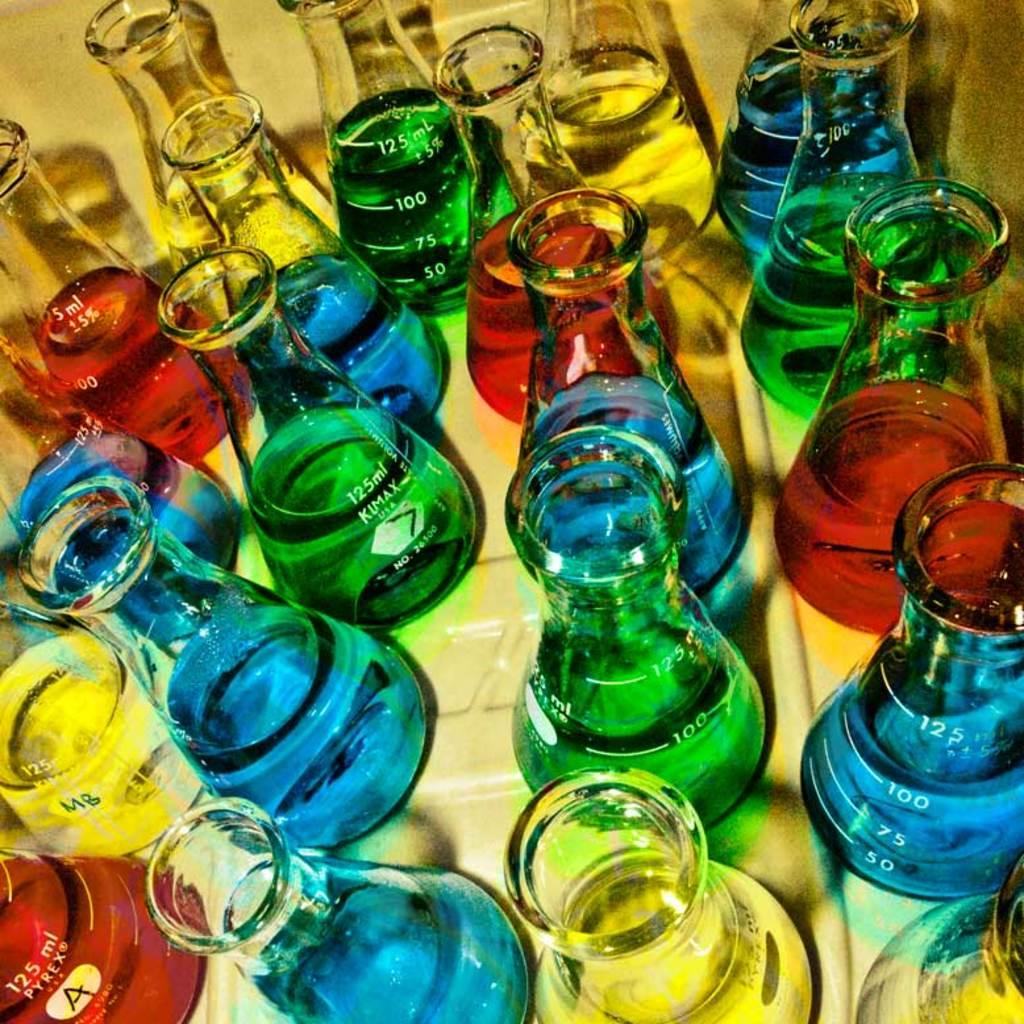<image>
Write a terse but informative summary of the picture. Many 125ml beakers are filled with blue, green, yellow, and red colored liquids. 